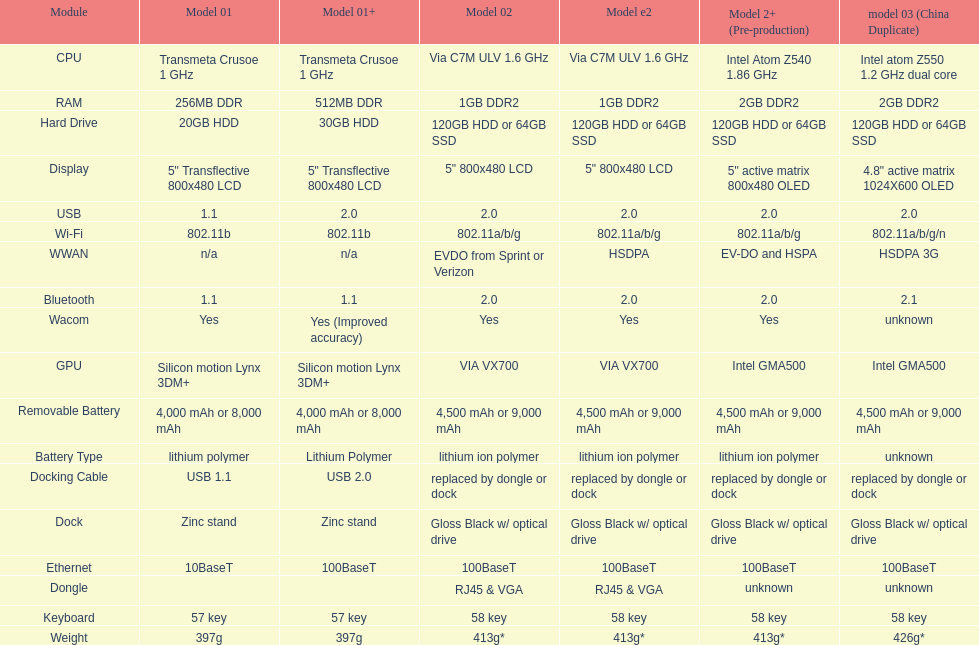What was the part that existed prior to usb? Display. 